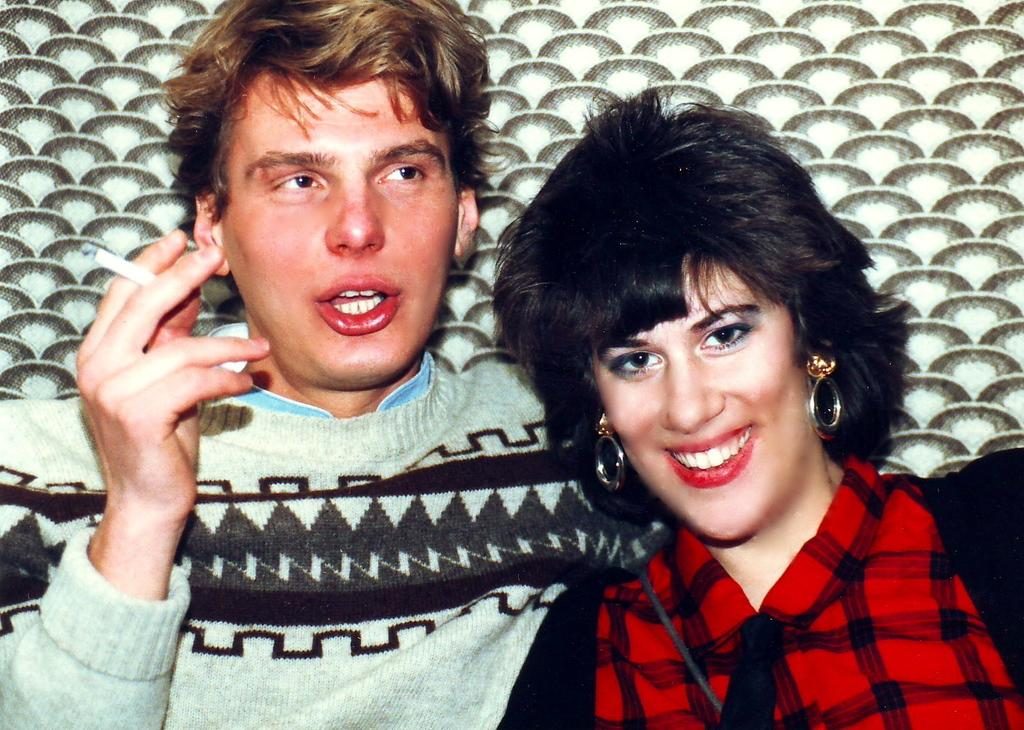How many people are in the image? There are two people in the image. What colors are the dresses worn by the people in the image? One person is wearing a black dress, one person is wearing a red dress, one person is wearing a green dress, and one person is wearing a blue dress. What colors can be seen in the background of the image? The background of the image includes brown, cream, and green colors. What is the chance of a tree growing in the image? There is no tree present in the image, so it is not possible to determine the chance of a tree growing. 